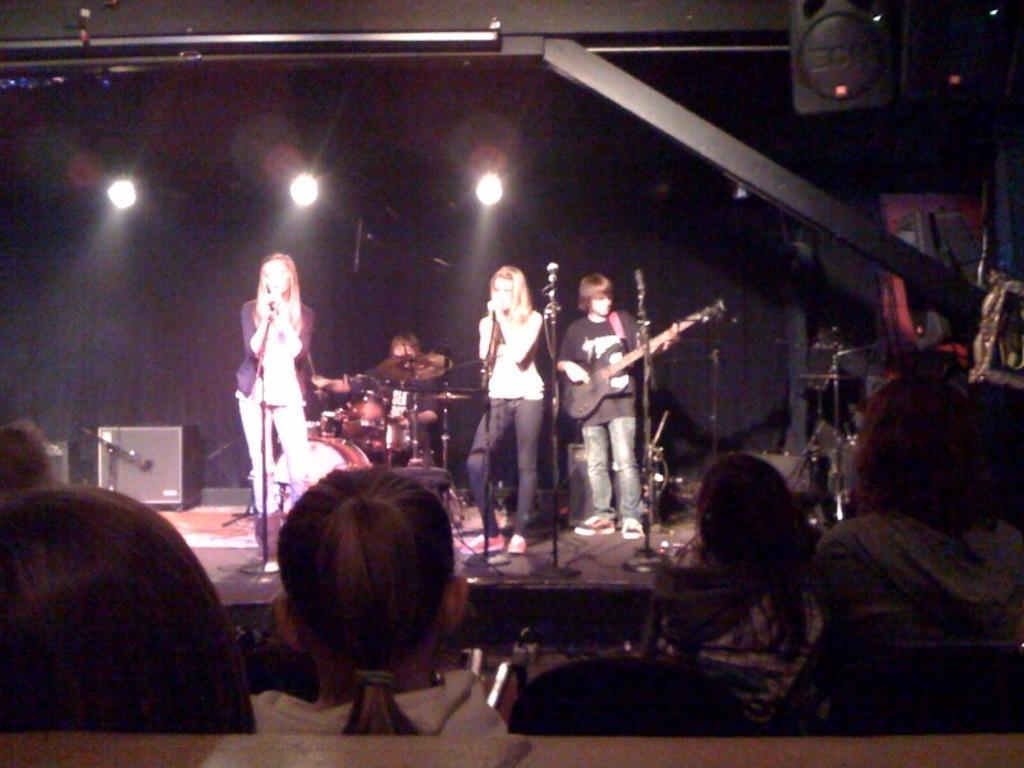Can you describe this image briefly? This is a picture of a stage performance. On the stage there are four persons and crowd is sitting in front of them. In the center of the image there is a woman standing and singing. On the right center there is another woman standing and singing. On the right a person is playing guitar. In the background a person is playing drums. In background it is dark it has three lights. 